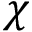<formula> <loc_0><loc_0><loc_500><loc_500>\chi</formula> 